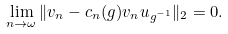<formula> <loc_0><loc_0><loc_500><loc_500>\lim _ { n \rightarrow \omega } \| v _ { n } - c _ { n } ( g ) v _ { n } u _ { g ^ { - 1 } } \| _ { 2 } = 0 .</formula> 